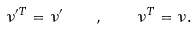Convert formula to latex. <formula><loc_0><loc_0><loc_500><loc_500>\nu ^ { \prime T } = \nu ^ { \prime } \quad , \quad \nu ^ { T } = \nu .</formula> 